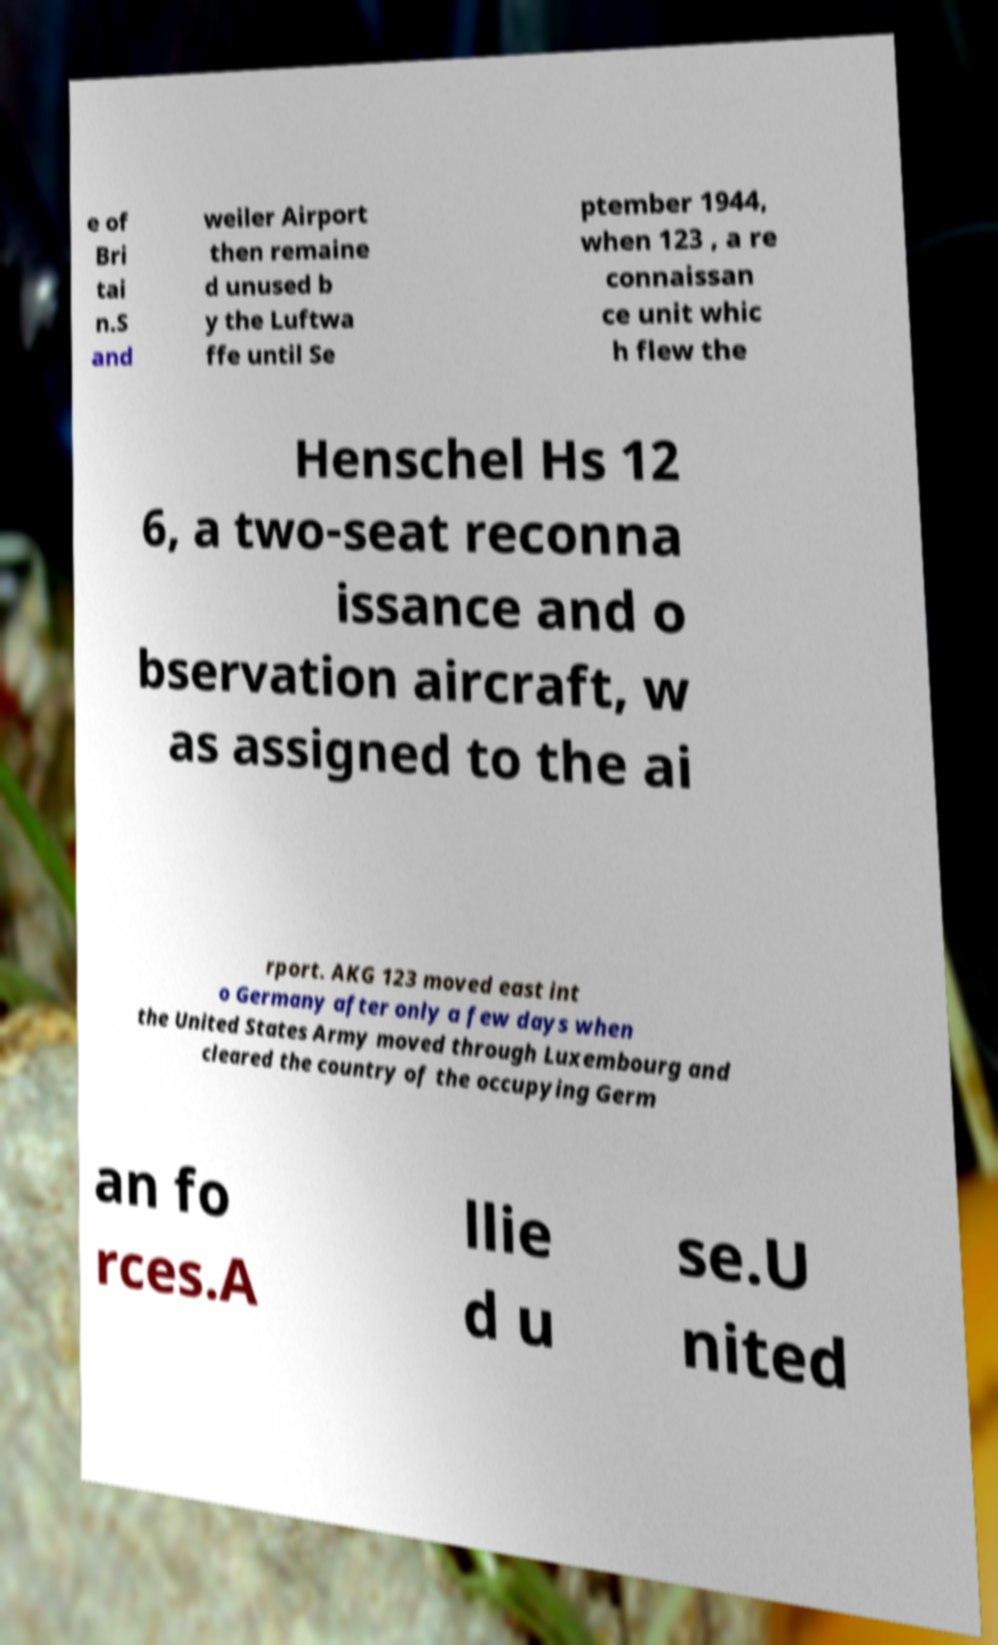Please read and relay the text visible in this image. What does it say? e of Bri tai n.S and weiler Airport then remaine d unused b y the Luftwa ffe until Se ptember 1944, when 123 , a re connaissan ce unit whic h flew the Henschel Hs 12 6, a two-seat reconna issance and o bservation aircraft, w as assigned to the ai rport. AKG 123 moved east int o Germany after only a few days when the United States Army moved through Luxembourg and cleared the country of the occupying Germ an fo rces.A llie d u se.U nited 